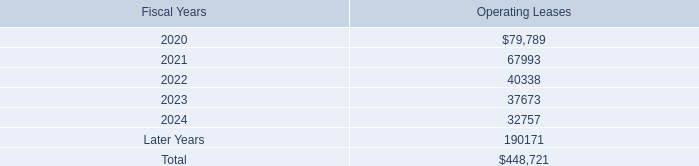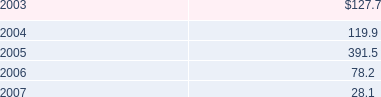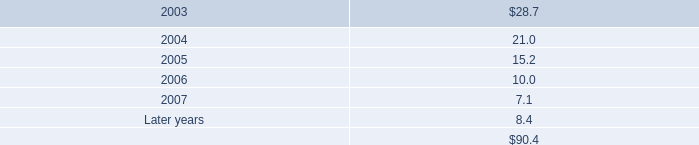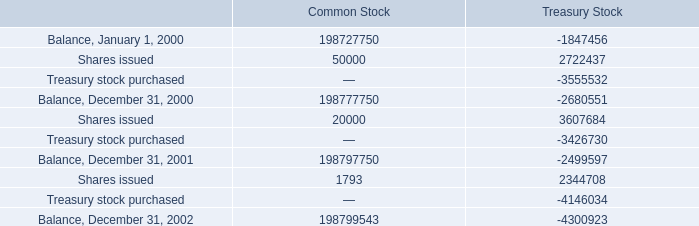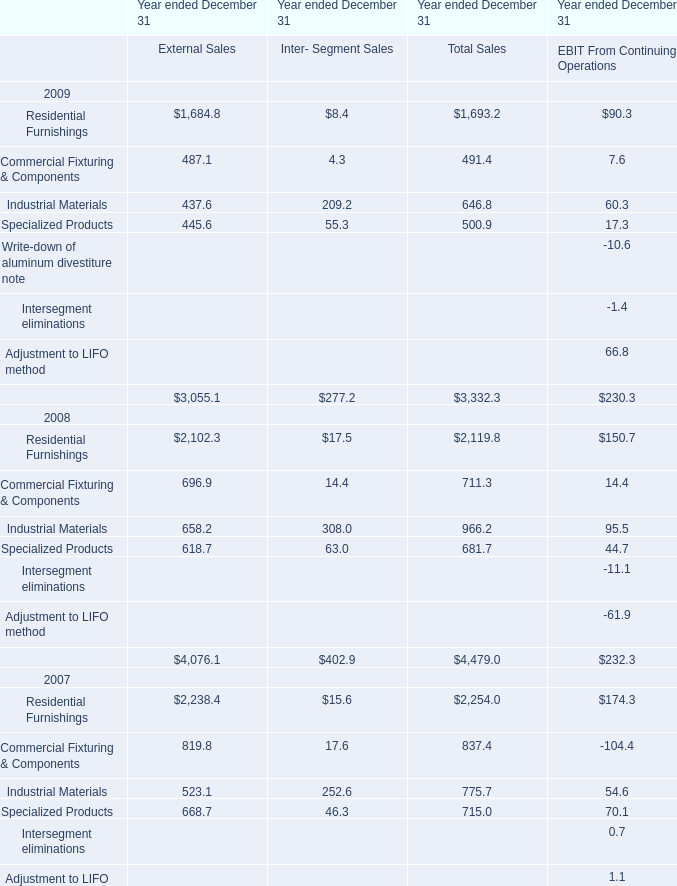What was the total amount of Inter- Segment Sales in 2009? 
Computations: (((8.4 + 4.3) + 209.2) + 55.3)
Answer: 277.2. 